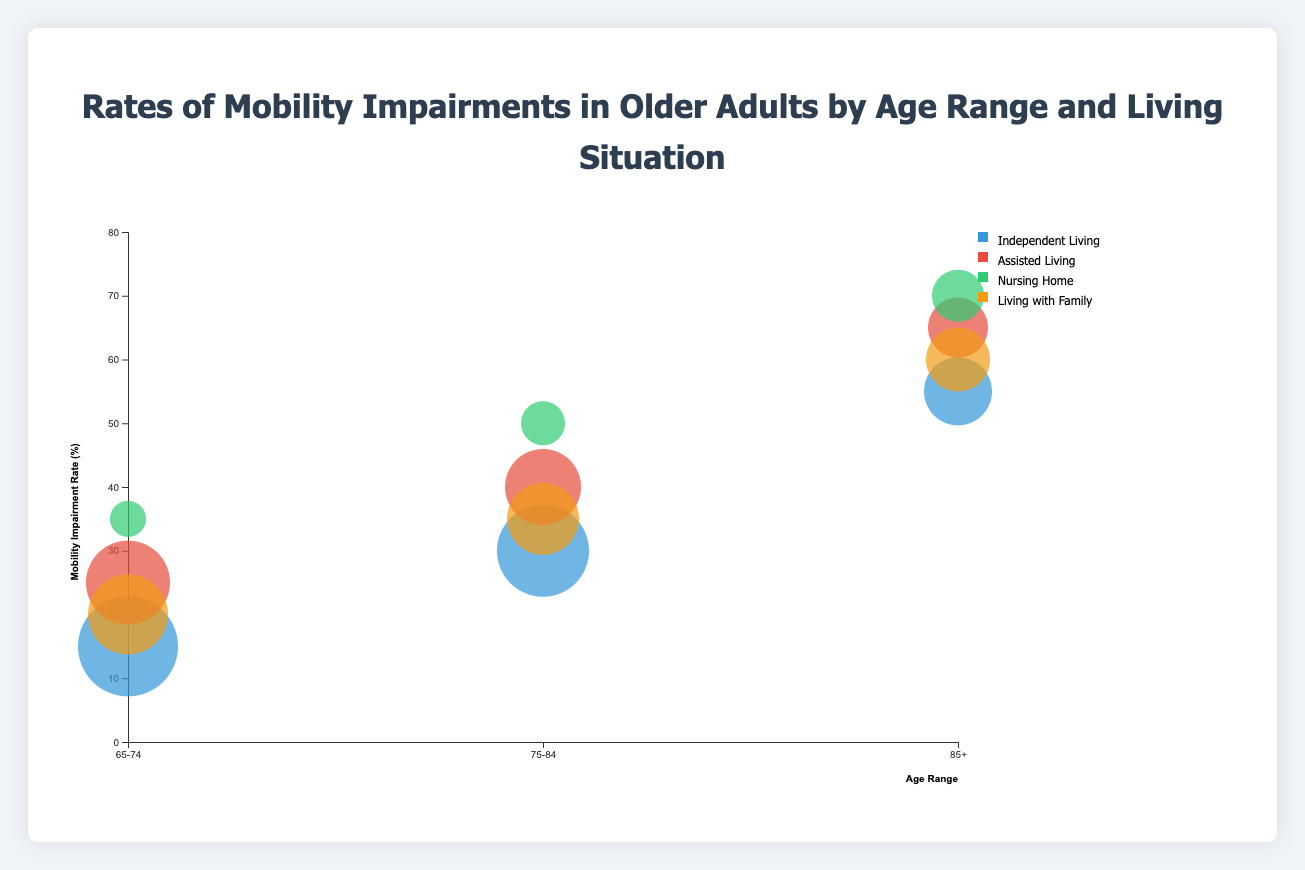What is the title of the figure? The title of the figure is displayed at the top center of the chart.
Answer: Rates of Mobility Impairments in Older Adults by Age Range and Living Situation What is the age range with the highest mobility impairment rate for those in Nursing Homes? To find the highest rate, look at the age ranges within the "Nursing Home" category and compare their rates. The highest rate is 70% for the 85+ age range.
Answer: 85+ Which living situation has the lowest mobility impairment rate for the 65-74 age range? In the 65-74 age range, compare the mobility impairment rates for different living situations. The lowest rate is 15% for Independent Living.
Answer: Independent Living How does the mobility impairment rate of those aged 75-84 who live with family compare to those in nursing homes of the same age range? For the 75-84 age range, compare the rates of "Living with Family" (35%) and "Nursing Home" (50%). The rate is lower for those living with family.
Answer: Lower What is the overall trend in mobility impairment rates as age increases? Observe the general pattern of bubble positions from left to right across different age ranges. Mobility impairment rates tend to increase as age increases.
Answer: Increases For individuals aged 85+, which living situation has the largest population size? Look at the sizes of the bubbles within the 85+ age range for all living situations and compare their sizes. The largest bubble corresponds to Independent Living with a population size of 600.
Answer: Independent Living Calculate the average mobility impairment rate for Independent Living across all age ranges. For Independent Living, add the mobility impairment rates for all age ranges and divide by the number of age ranges: (15 + 30 + 55)/3 = 33.33%
Answer: 33.33% Which living situations have overlapping mobility impairment rates for any age range? Compare the rates visually across all age ranges. For example, in the 85+ age range, both Living with Family (60%) and Assisted Living (65%) have close and possibly overlapping rates.
Answer: Assisted Living and Living with Family (85+) Between Assisted Living and Nursing Home, which one has a higher mobility impairment rate for those aged 65-74? Compare the rates for the 65-74 age range. Assisted Living has a rate of 25%, whereas Nursing Home has a rate of 35%. Nursing Home has a higher rate.
Answer: Nursing Home Is there any living situation where the mobility impairment rate decreases as the age range increases? Examine each living situation and its trend across age ranges. None of the living situations show a decrease; all either increase or remain static.
Answer: No 